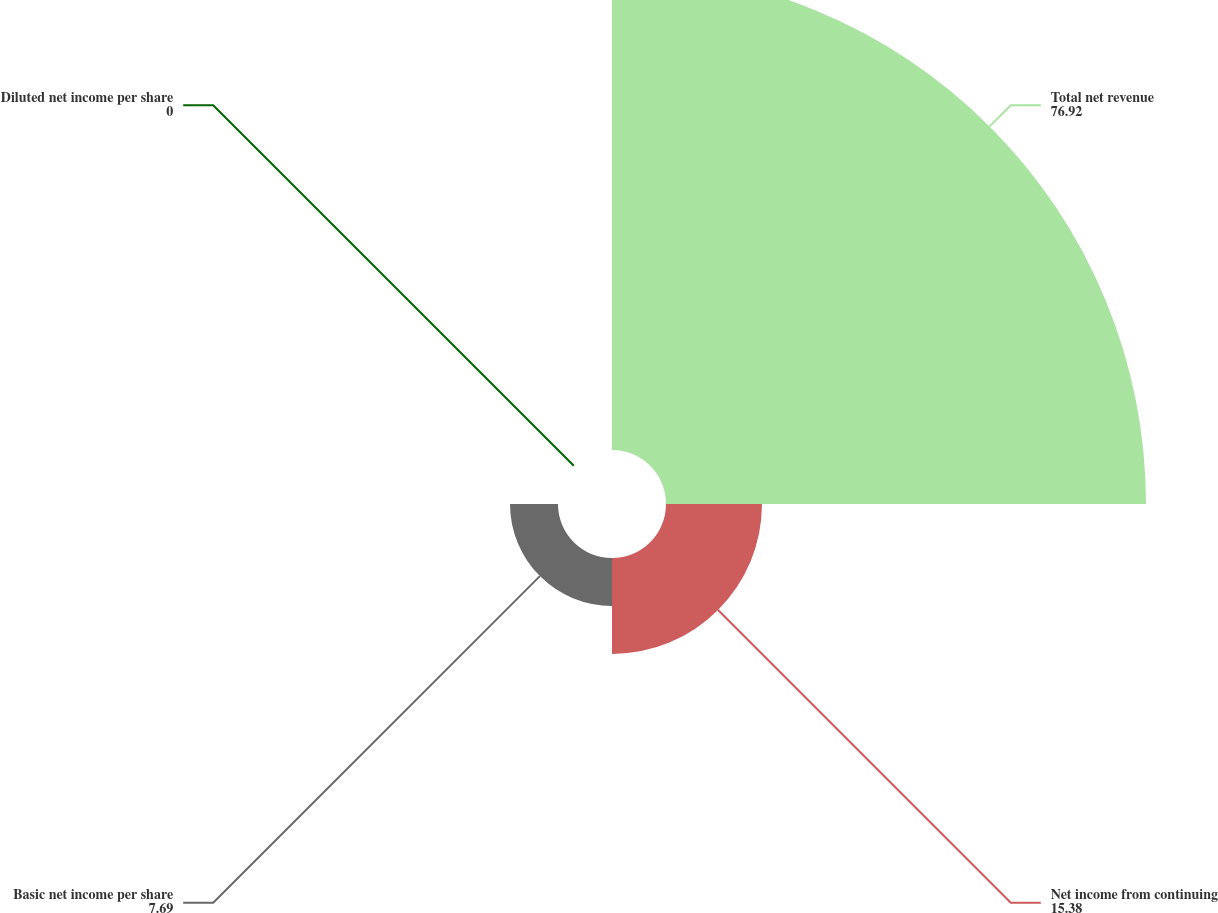Convert chart. <chart><loc_0><loc_0><loc_500><loc_500><pie_chart><fcel>Total net revenue<fcel>Net income from continuing<fcel>Basic net income per share<fcel>Diluted net income per share<nl><fcel>76.92%<fcel>15.38%<fcel>7.69%<fcel>0.0%<nl></chart> 